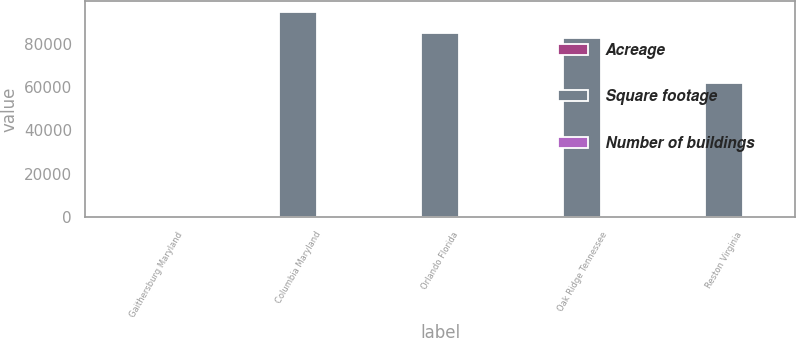<chart> <loc_0><loc_0><loc_500><loc_500><stacked_bar_chart><ecel><fcel>Gaithersburg Maryland<fcel>Columbia Maryland<fcel>Orlando Florida<fcel>Oak Ridge Tennessee<fcel>Reston Virginia<nl><fcel>Acreage<fcel>1<fcel>1<fcel>1<fcel>1<fcel>1<nl><fcel>Square footage<fcel>7.85<fcel>95000<fcel>85000<fcel>83000<fcel>62000<nl><fcel>Number of buildings<fcel>44.8<fcel>7.3<fcel>8.5<fcel>8.4<fcel>2.6<nl></chart> 